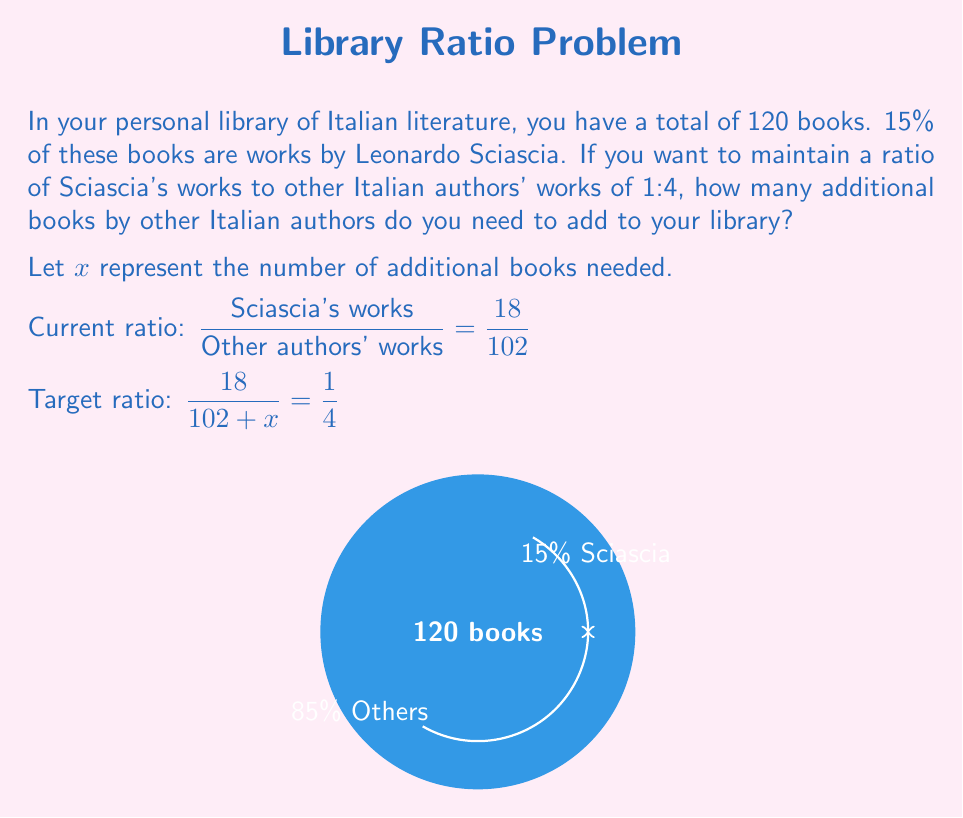Teach me how to tackle this problem. Let's solve this step-by-step:

1) First, calculate the number of Sciascia's works:
   15% of 120 = $0.15 \times 120 = 18$ books

2) The remaining books are by other authors:
   120 - 18 = 102 books

3) We want to achieve a ratio of 1:4, which means:
   $\frac{\text{Sciascia's works}}{\text{Other authors' works}} = \frac{1}{4}$

4) Set up the equation:
   $\frac{18}{102 + x} = \frac{1}{4}$

5) Cross multiply:
   $4(18) = 1(102 + x)$
   $72 = 102 + x$

6) Solve for $x$:
   $x = 72 - 102 = -30$

7) The negative result means we need to remove 30 books by other authors to achieve the desired ratio.

8) However, since we can't remove books from our existing collection, we need to add Sciascia's works instead.

9) To find how many of Sciascia's works to add, set up a new equation:
   $\frac{18 + y}{102} = \frac{1}{4}$

10) Solve for $y$:
    $4(18 + y) = 102$
    $72 + 4y = 102$
    $4y = 30$
    $y = 7.5$

11) Since we can't add half a book, we round up to 8.

Therefore, to achieve the desired ratio of 1:4, we need to add 8 more of Sciascia's works to our library.
Answer: Add 8 of Sciascia's works 